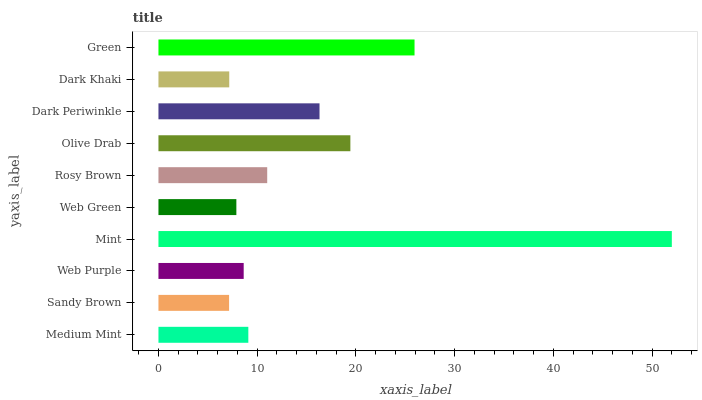Is Sandy Brown the minimum?
Answer yes or no. Yes. Is Mint the maximum?
Answer yes or no. Yes. Is Web Purple the minimum?
Answer yes or no. No. Is Web Purple the maximum?
Answer yes or no. No. Is Web Purple greater than Sandy Brown?
Answer yes or no. Yes. Is Sandy Brown less than Web Purple?
Answer yes or no. Yes. Is Sandy Brown greater than Web Purple?
Answer yes or no. No. Is Web Purple less than Sandy Brown?
Answer yes or no. No. Is Rosy Brown the high median?
Answer yes or no. Yes. Is Medium Mint the low median?
Answer yes or no. Yes. Is Dark Khaki the high median?
Answer yes or no. No. Is Web Green the low median?
Answer yes or no. No. 